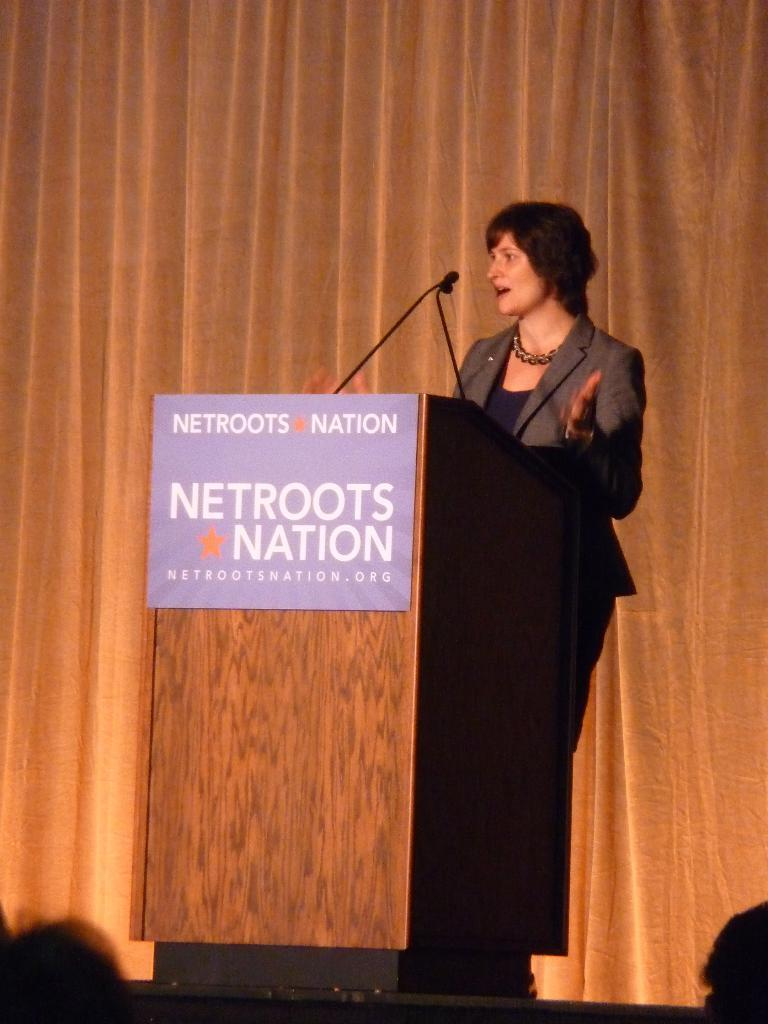Provide a one-sentence caption for the provided image. A woman speaks at a lectern on a stage for a netroots nation event. 